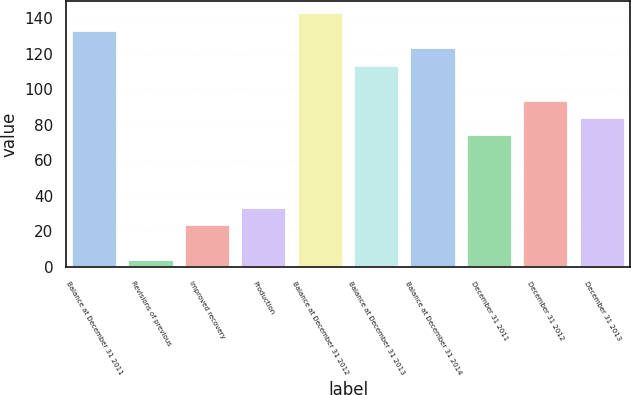<chart> <loc_0><loc_0><loc_500><loc_500><bar_chart><fcel>Balance at December 31 2011<fcel>Revisions of previous<fcel>Improved recovery<fcel>Production<fcel>Balance at December 31 2012<fcel>Balance at December 31 2013<fcel>Balance at December 31 2014<fcel>December 31 2011<fcel>December 31 2012<fcel>December 31 2013<nl><fcel>132.8<fcel>4<fcel>23.6<fcel>33.4<fcel>142.6<fcel>113.2<fcel>123<fcel>74<fcel>93.6<fcel>83.8<nl></chart> 